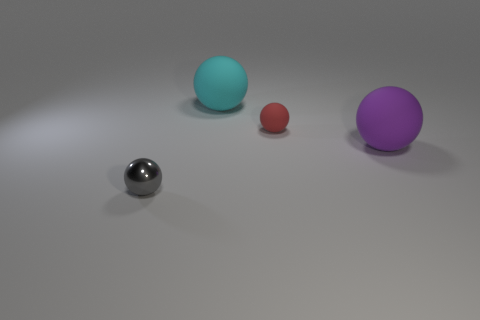There is a thing that is both on the left side of the small red thing and behind the small gray shiny ball; how big is it?
Provide a succinct answer. Large. There is a big object behind the tiny sphere right of the metal object; what is its shape?
Offer a terse response. Sphere. Is there any other thing that is the same shape as the tiny red rubber thing?
Make the answer very short. Yes. Are there the same number of small metal things in front of the small metallic thing and purple metal things?
Offer a very short reply. Yes. There is a metallic ball; does it have the same color as the small ball right of the big cyan matte sphere?
Give a very brief answer. No. The ball that is in front of the cyan sphere and to the left of the red thing is what color?
Your answer should be compact. Gray. What number of large things are on the left side of the small sphere that is behind the small gray metal object?
Offer a terse response. 1. Is there a big thing of the same shape as the tiny red matte object?
Your answer should be compact. Yes. There is a tiny object that is right of the tiny gray shiny ball; is its shape the same as the thing to the left of the big cyan ball?
Offer a terse response. Yes. What number of things are cyan spheres or small gray metal things?
Offer a terse response. 2. 